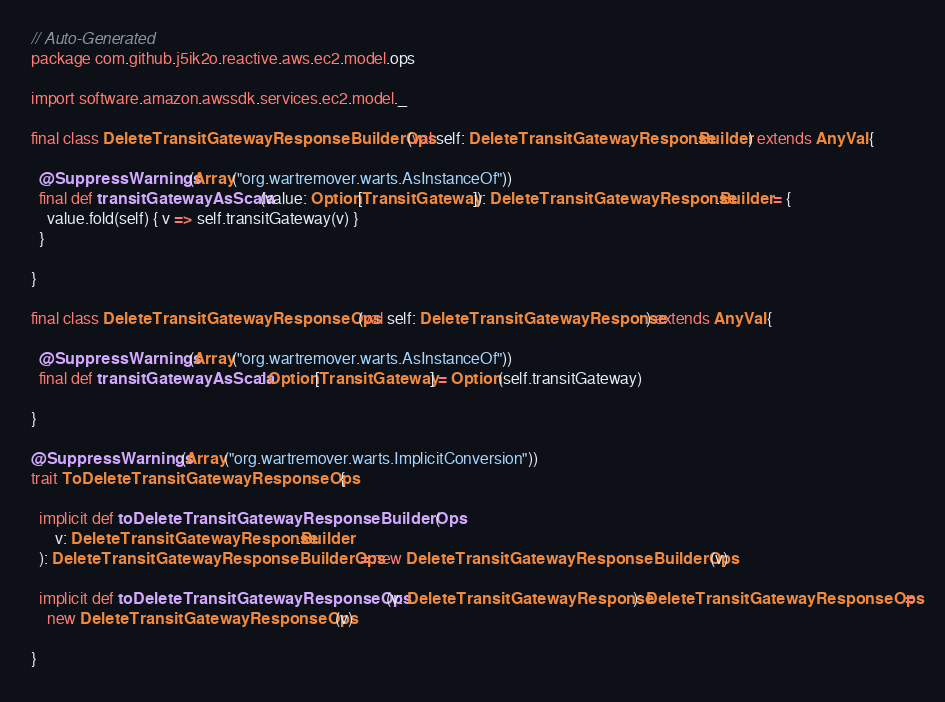<code> <loc_0><loc_0><loc_500><loc_500><_Scala_>// Auto-Generated
package com.github.j5ik2o.reactive.aws.ec2.model.ops

import software.amazon.awssdk.services.ec2.model._

final class DeleteTransitGatewayResponseBuilderOps(val self: DeleteTransitGatewayResponse.Builder) extends AnyVal {

  @SuppressWarnings(Array("org.wartremover.warts.AsInstanceOf"))
  final def transitGatewayAsScala(value: Option[TransitGateway]): DeleteTransitGatewayResponse.Builder = {
    value.fold(self) { v => self.transitGateway(v) }
  }

}

final class DeleteTransitGatewayResponseOps(val self: DeleteTransitGatewayResponse) extends AnyVal {

  @SuppressWarnings(Array("org.wartremover.warts.AsInstanceOf"))
  final def transitGatewayAsScala: Option[TransitGateway] = Option(self.transitGateway)

}

@SuppressWarnings(Array("org.wartremover.warts.ImplicitConversion"))
trait ToDeleteTransitGatewayResponseOps {

  implicit def toDeleteTransitGatewayResponseBuilderOps(
      v: DeleteTransitGatewayResponse.Builder
  ): DeleteTransitGatewayResponseBuilderOps = new DeleteTransitGatewayResponseBuilderOps(v)

  implicit def toDeleteTransitGatewayResponseOps(v: DeleteTransitGatewayResponse): DeleteTransitGatewayResponseOps =
    new DeleteTransitGatewayResponseOps(v)

}
</code> 